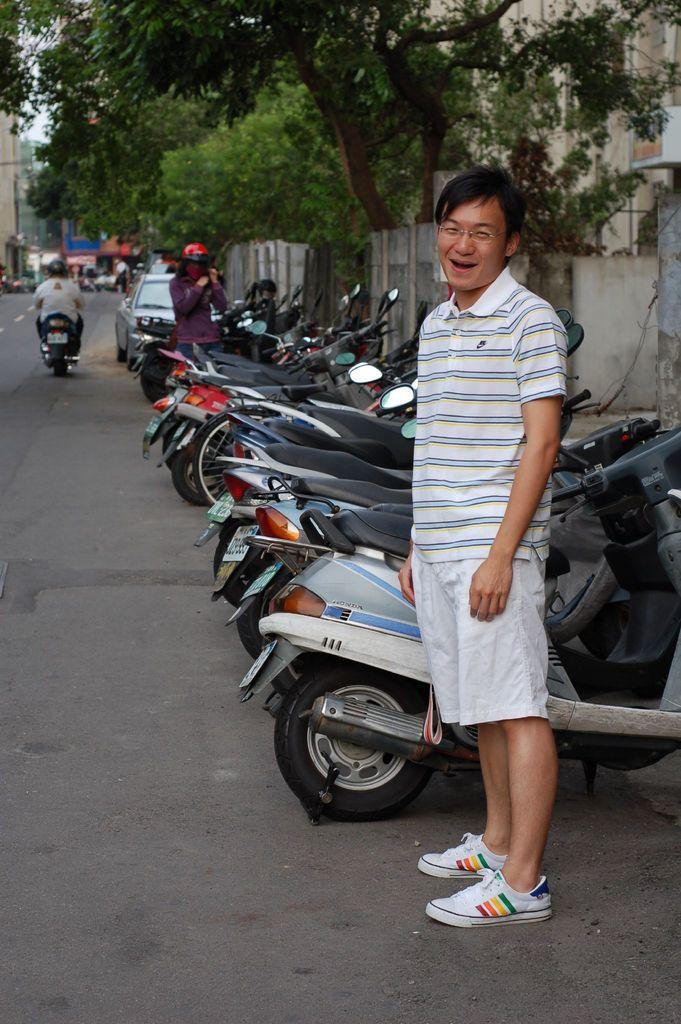Describe this image in one or two sentences. In this image we can see a man is standing on the pavement. In the background, we can see two people, vehicles, boundary wall and road. At the top of the image we can see trees and buildings. 